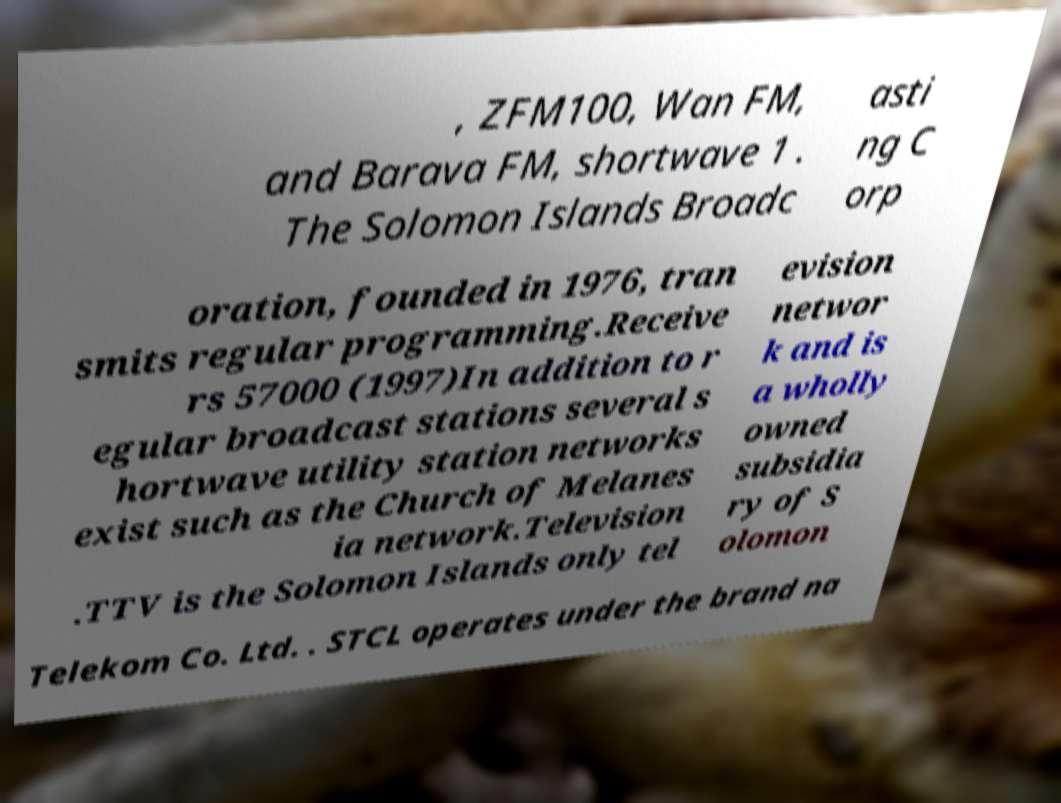Could you assist in decoding the text presented in this image and type it out clearly? , ZFM100, Wan FM, and Barava FM, shortwave 1 . The Solomon Islands Broadc asti ng C orp oration, founded in 1976, tran smits regular programming.Receive rs 57000 (1997)In addition to r egular broadcast stations several s hortwave utility station networks exist such as the Church of Melanes ia network.Television .TTV is the Solomon Islands only tel evision networ k and is a wholly owned subsidia ry of S olomon Telekom Co. Ltd. . STCL operates under the brand na 